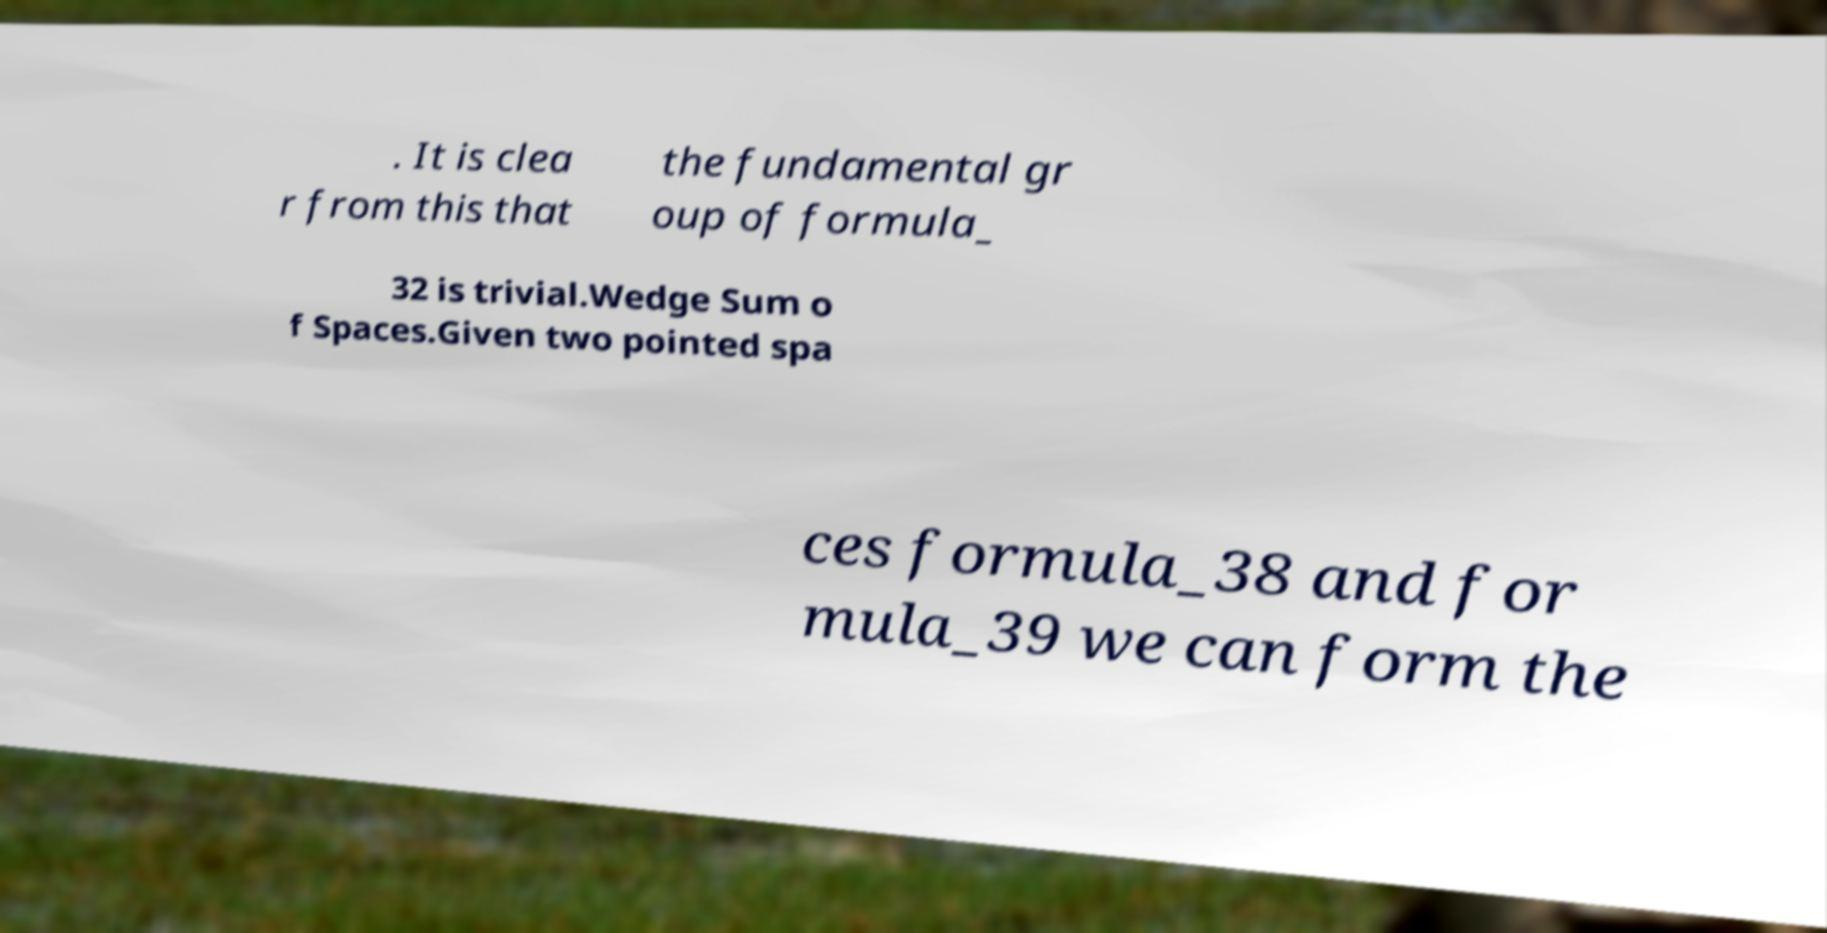Please read and relay the text visible in this image. What does it say? . It is clea r from this that the fundamental gr oup of formula_ 32 is trivial.Wedge Sum o f Spaces.Given two pointed spa ces formula_38 and for mula_39 we can form the 